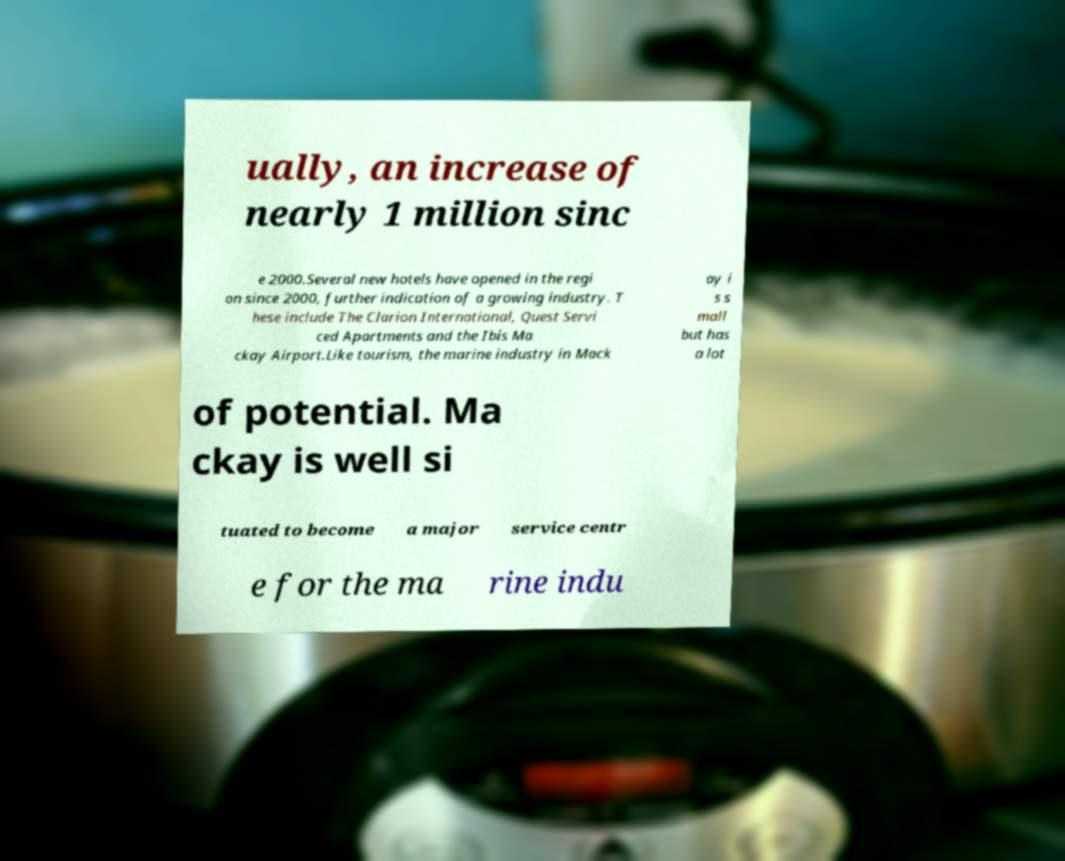I need the written content from this picture converted into text. Can you do that? ually, an increase of nearly 1 million sinc e 2000.Several new hotels have opened in the regi on since 2000, further indication of a growing industry. T hese include The Clarion International, Quest Servi ced Apartments and the Ibis Ma ckay Airport.Like tourism, the marine industry in Mack ay i s s mall but has a lot of potential. Ma ckay is well si tuated to become a major service centr e for the ma rine indu 